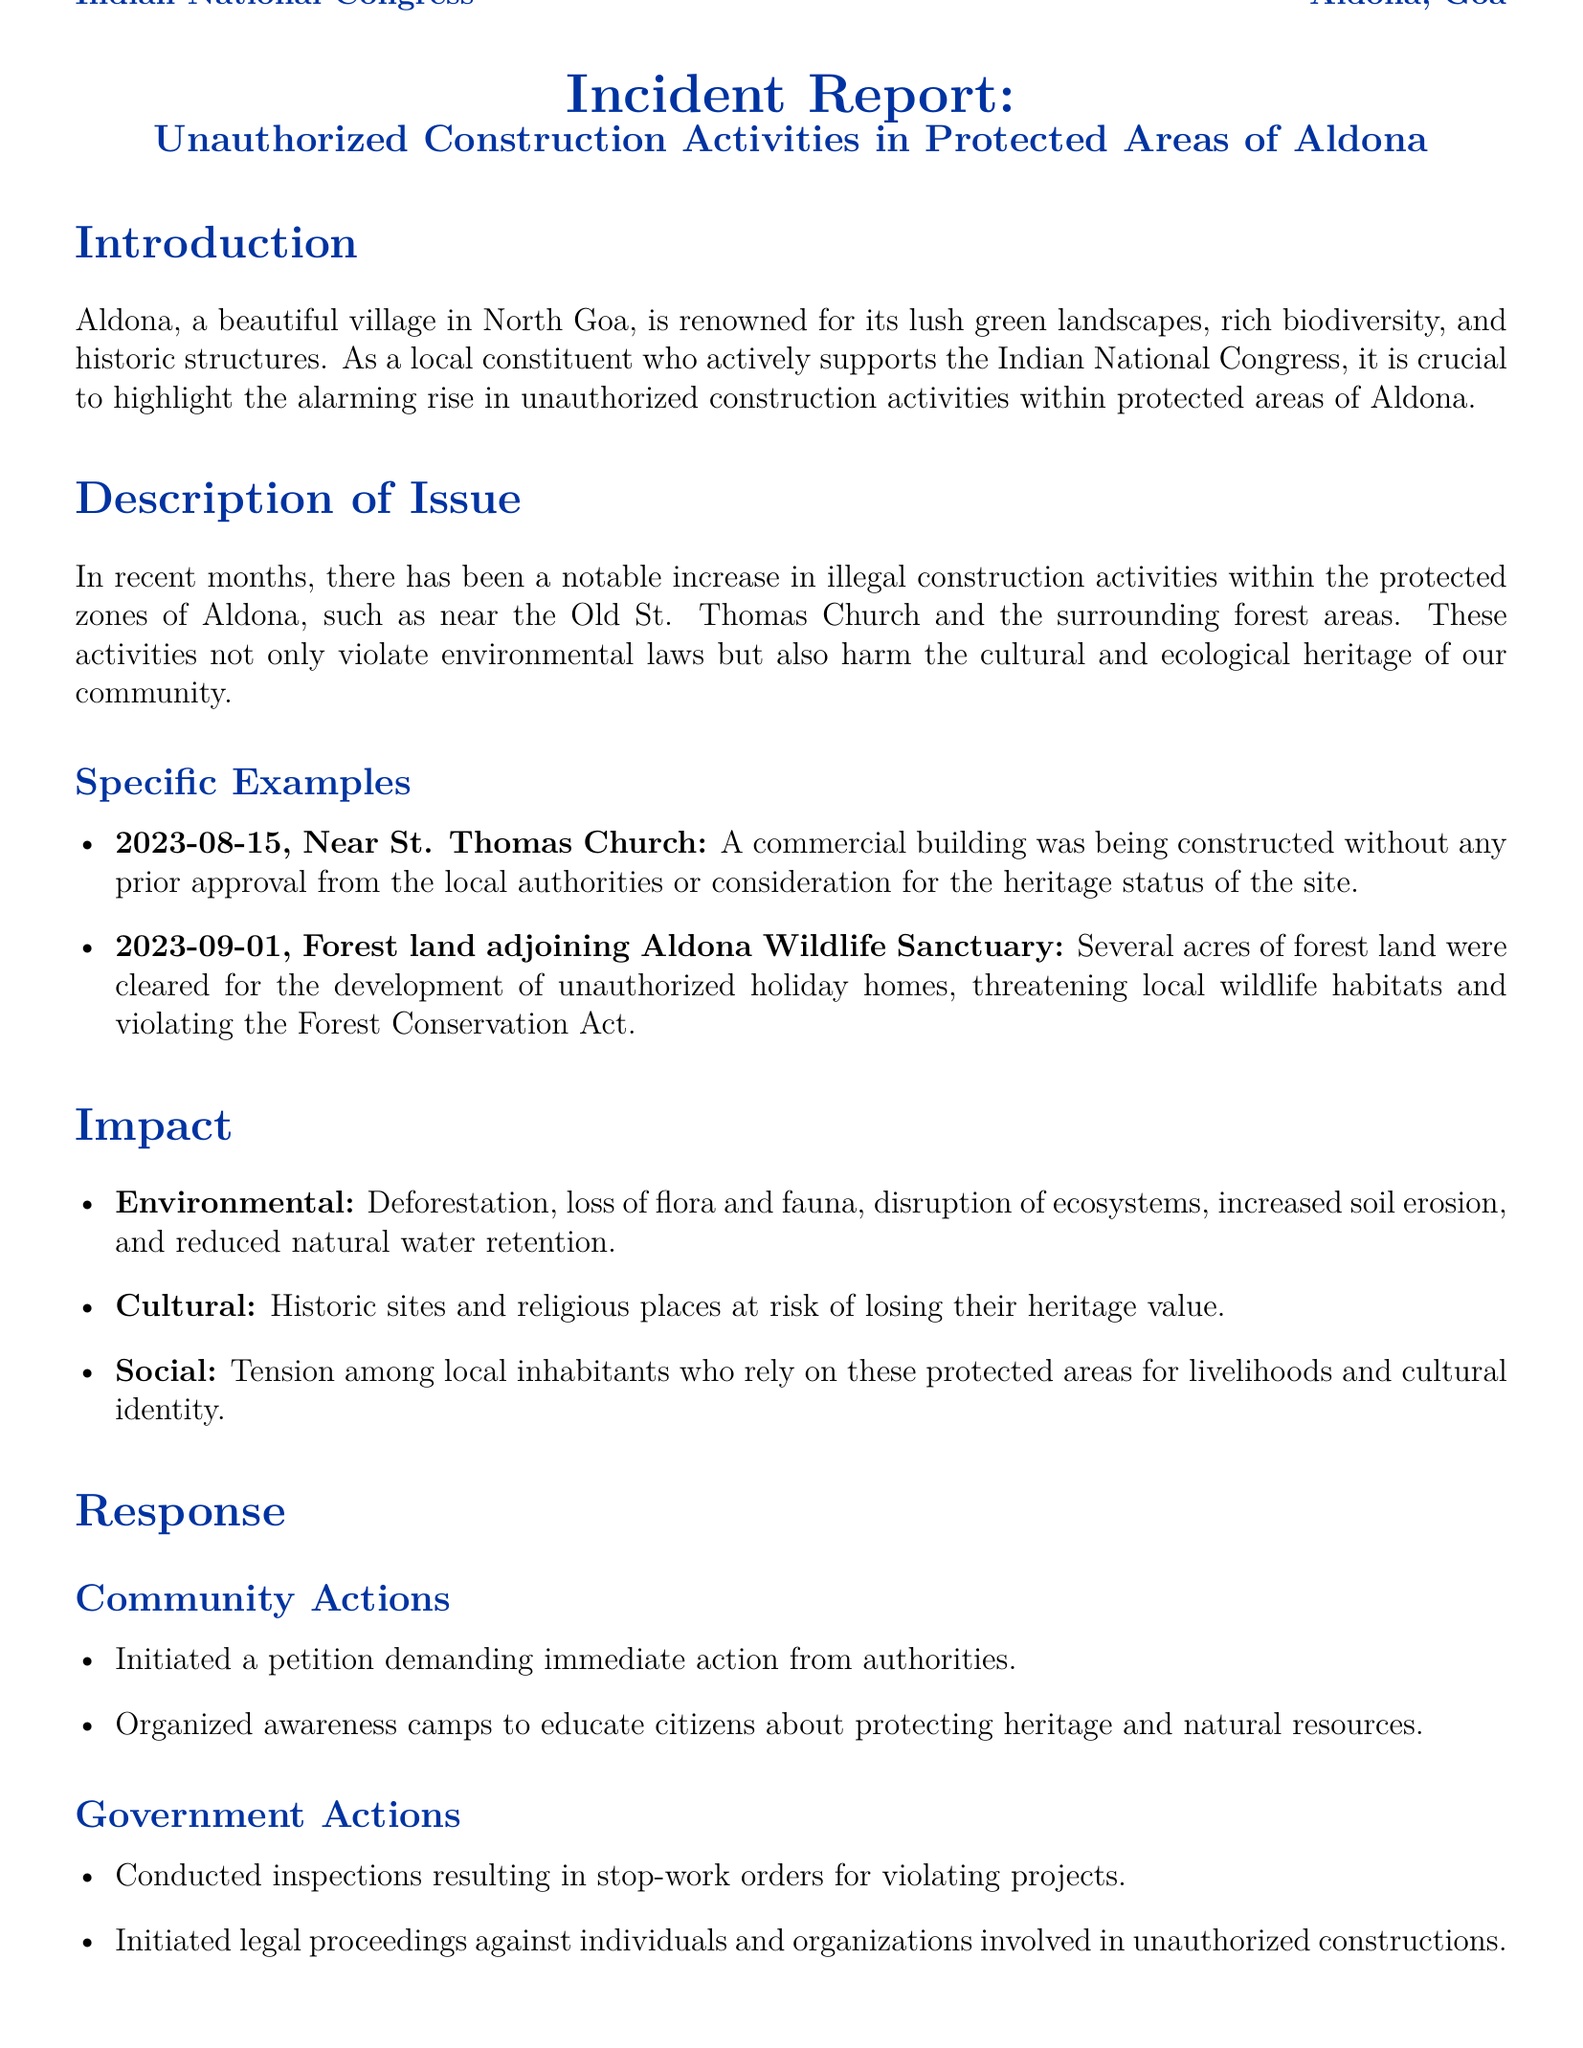What is the main issue discussed in the report? The report discusses the rise in unauthorized construction activities in protected areas of Aldona.
Answer: Unauthorized construction activities How many specific examples of unauthorized construction are mentioned? Two specific examples of unauthorized construction activities are provided in the document.
Answer: Two What date was construction near St. Thomas Church noted? The incident near St. Thomas Church was recorded on August 15, 2023.
Answer: 2023-08-15 What is one cultural impact of the unauthorized construction mentioned? The report highlights that historic sites and religious places are at risk of losing their heritage value.
Answer: Heritage value What is the name of the wildlife sanctuary mentioned in the document? The document mentions the Aldona Wildlife Sanctuary in relation to unauthorized construction activities.
Answer: Aldona Wildlife Sanctuary What action was taken by the community in response to the issue? The community initiated a petition demanding immediate action from authorities regarding unauthorized constructions.
Answer: Petition How many acres of forest land were cleared for unauthorized holiday homes? The document does not specify the exact number of acres cleared for unauthorized holiday homes.
Answer: Several acres What color scheme is used in the title format? The title format utilizes a color scheme based on the Indian National Congress's color.
Answer: Congress blue What call to action is presented in the report? The call to action urges residents and stakeholders to unite against unauthorized construction activities.
Answer: Unite against unauthorized construction activities 